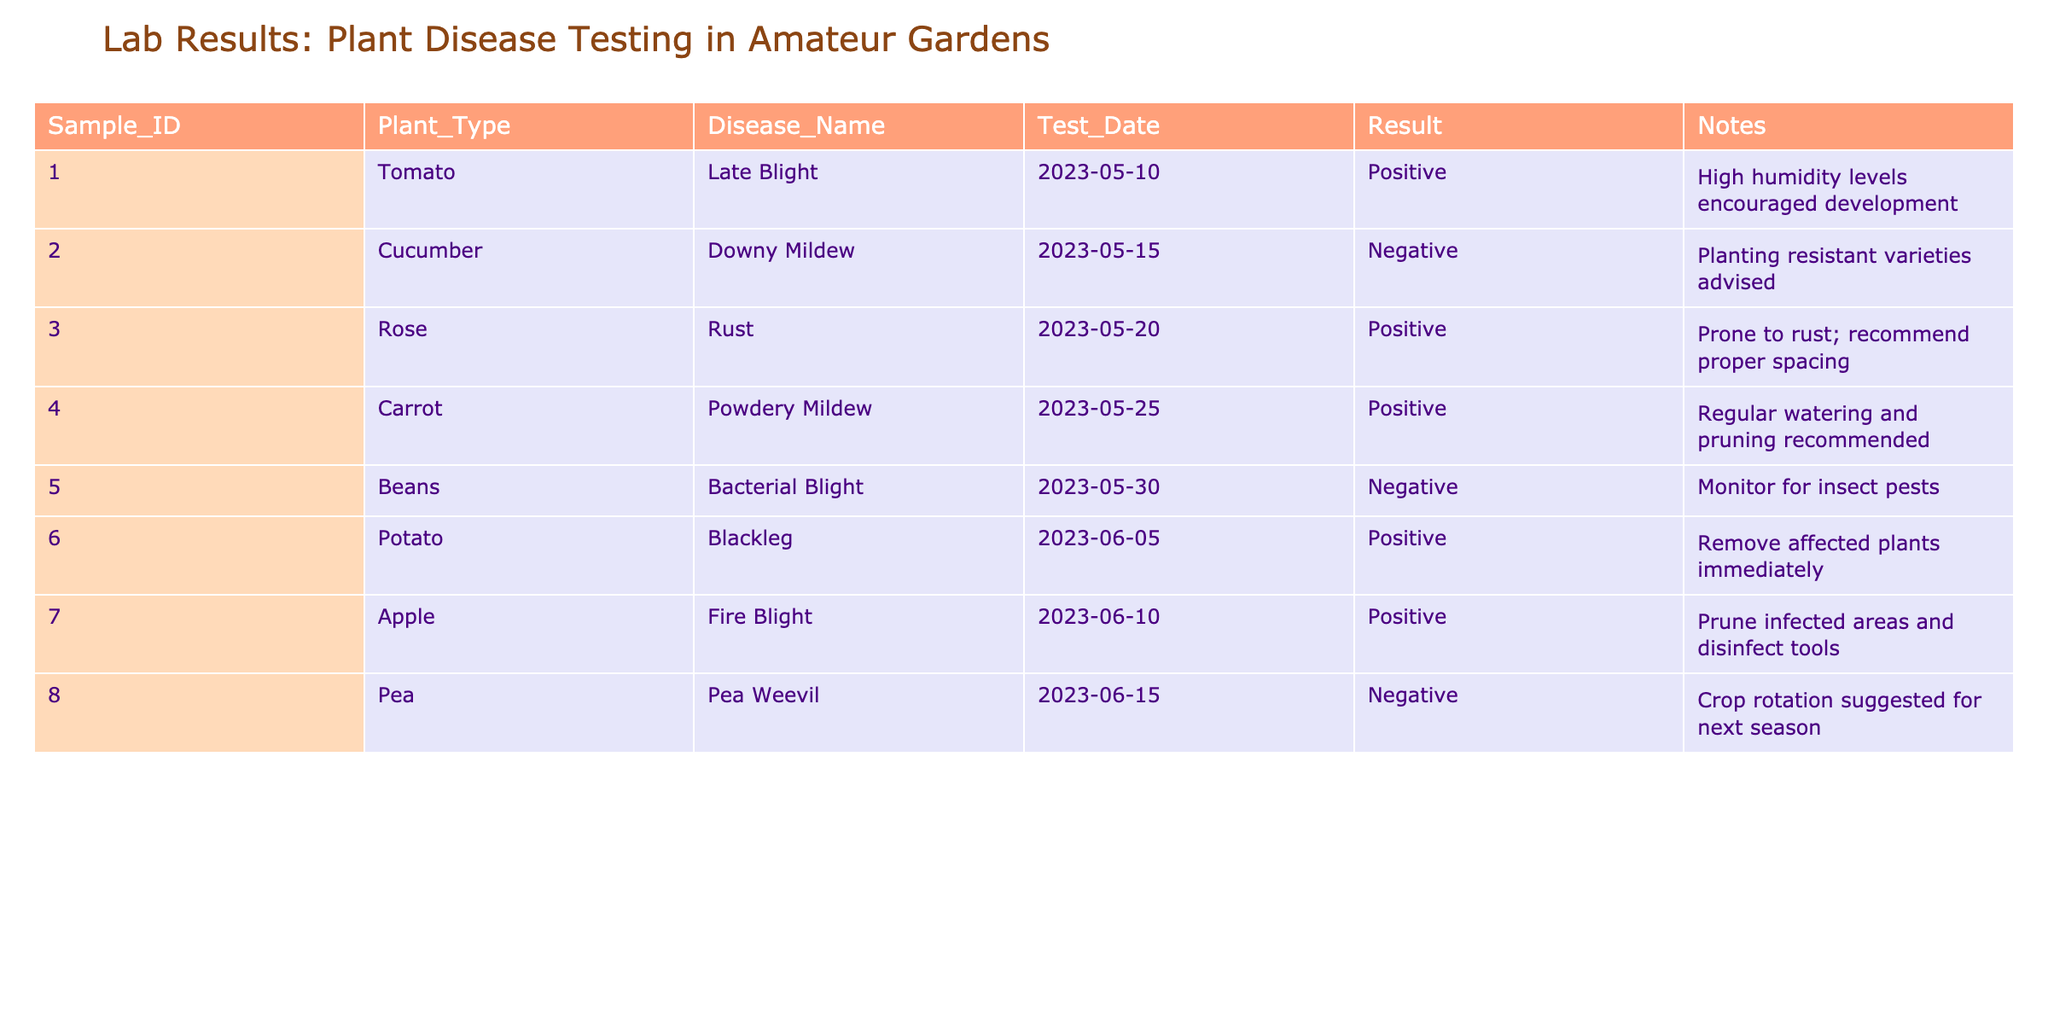What disease was detected in the Potato sample? The table shows that the disease detected in the Potato sample is Blackleg based on the Disease_Name column for Sample_ID 006.
Answer: Blackleg How many positive results were recorded in total? By counting the number of occurrences where the Result is 'Positive', we see that there are four instances: Late Blight, Rust, Powdery Mildew, and Blackleg.
Answer: Four Did the Cucumber sample test positive for any diseases? Looking at the Result for the Cucumber sample (Sample_ID 002), it is recorded as 'Negative', indicating that no disease was detected.
Answer: No Which Plant Type had the earliest test date? The earliest date listed in the Test_Date column is 2023-05-10 for the Tomato sample with Sample_ID 001. Hence, Tomato had the earliest test date.
Answer: Tomato Is it true that both the Beans and Pea samples tested negative? The Result for Beans (Sample_ID 005) is 'Negative' and the Result for Pea (Sample_ID 008) is also 'Negative', confirming that both samples did not test positive for any diseases.
Answer: Yes What is the most common disease found in the samples tested? By analyzing the Disease_Name column, Blackleg, Late Blight, Rust, and Powdery Mildew were each detected in one unique sample, making them common among the samples. However, no disease was repeated among the test results.
Answer: No common disease What recommendations were made for the Rose sample? The Notes section for the Rose sample under Sample_ID 003 states that proper spacing is recommended, indicating a need for better management practices to avoid rust disease.
Answer: Proper spacing Which diseases are suggested for further monitoring or prevention based on test results? The notes recommend monitoring for insect pests for Beans and suggest crop rotation for Peas as preventive actions. Thus, these two samples indicate a necessity for additional vigilance.
Answer: Beans and Peas How many samples tested positive for diseases related to fungi? The positive results related to fungi are Late Blight (Tomato), Downy Mildew (Cucumber), and Powdery Mildew (Carrot). This adds up to three samples testing positive for fungal diseases.
Answer: Three 